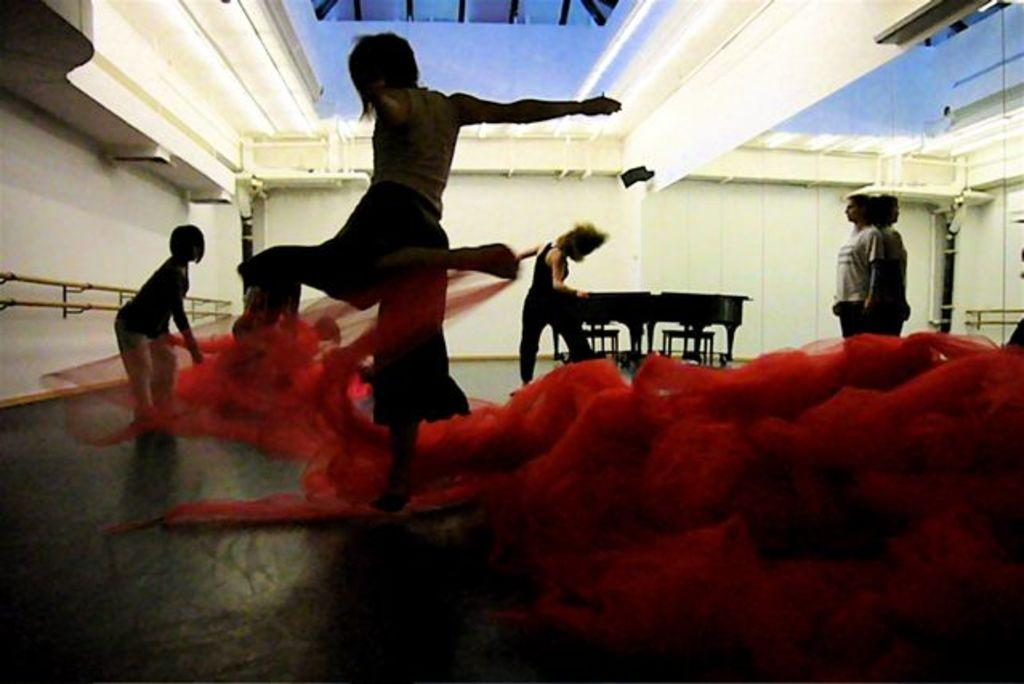What object is located on the right side of the image? There is a mirror on the right side of the image. What does the mirror reflect in the image? The mirror reflects a person and a wall in the image. How many people are visible in the image? There are people in the image. What type of furniture can be seen in the image? There are chairs and a table in the image. What type of engine is visible in the image? There is no engine present in the image. How does the system work in the image? There is no system mentioned or depicted in the image. 